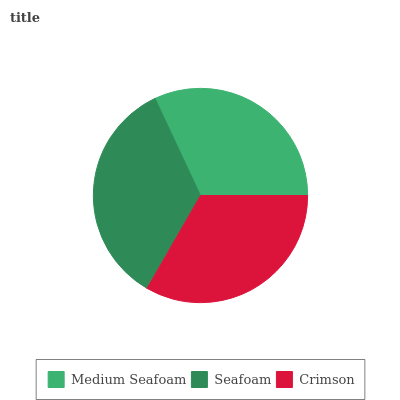Is Medium Seafoam the minimum?
Answer yes or no. Yes. Is Seafoam the maximum?
Answer yes or no. Yes. Is Crimson the minimum?
Answer yes or no. No. Is Crimson the maximum?
Answer yes or no. No. Is Seafoam greater than Crimson?
Answer yes or no. Yes. Is Crimson less than Seafoam?
Answer yes or no. Yes. Is Crimson greater than Seafoam?
Answer yes or no. No. Is Seafoam less than Crimson?
Answer yes or no. No. Is Crimson the high median?
Answer yes or no. Yes. Is Crimson the low median?
Answer yes or no. Yes. Is Seafoam the high median?
Answer yes or no. No. Is Medium Seafoam the low median?
Answer yes or no. No. 